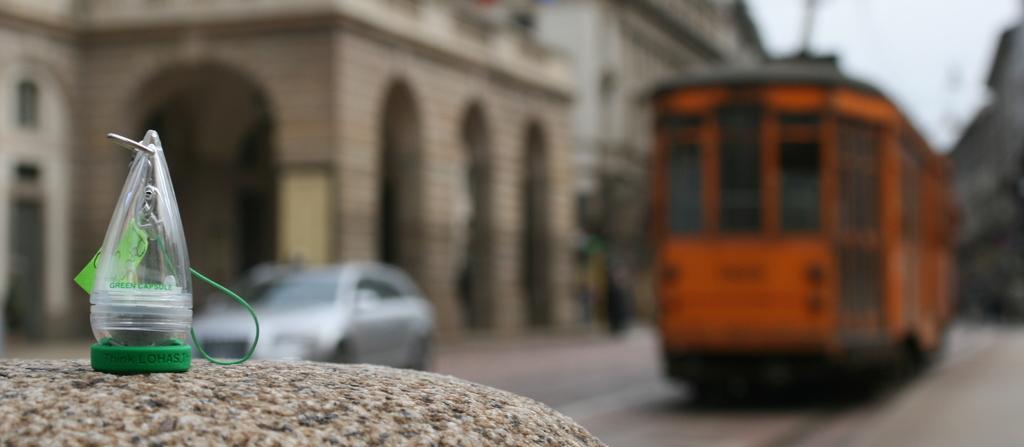Please provide a concise description of this image. In this image I can see there is a plastic thing on the left side on a stone, on the right side it looks like a train in orange color. There are buildings, at the bottom there is the car moving on the road. 